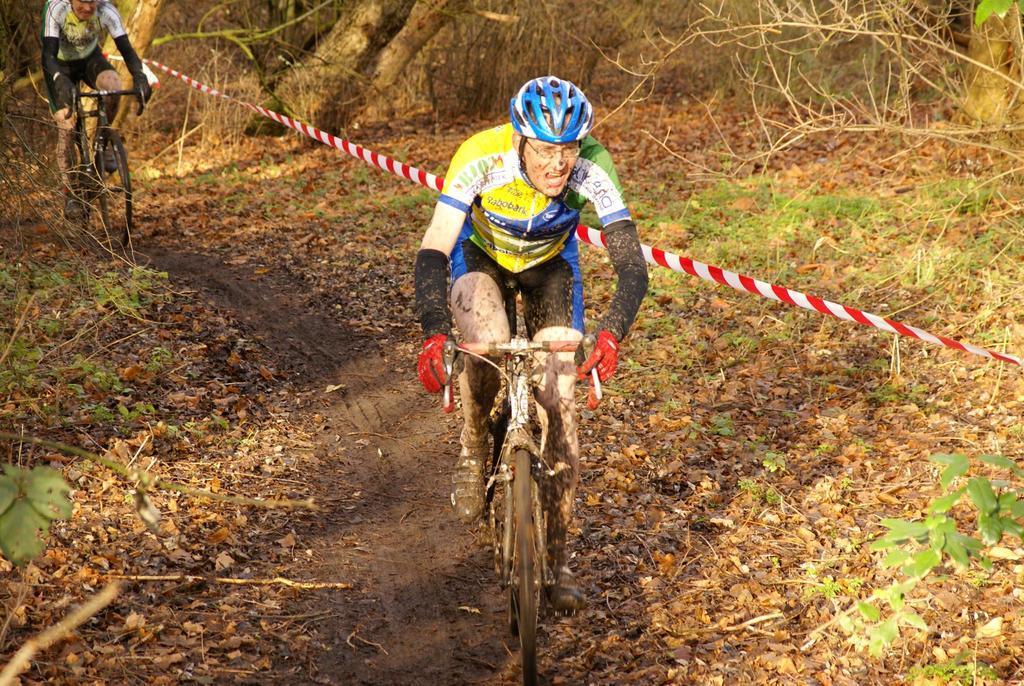How many people are in the image? There are two people in the image. What are the people wearing on their heads? The people are wearing helmets. What activity are the people engaged in? The people are riding bicycles. What type of vegetation can be seen in the image? There are plants in the image. What additional objects can be seen on the ground? Dry leaves are present in the image. What is the rope used for in the image? The purpose of the rope is not clear from the image. How many babies are being carried by the ducks in the image? There are no ducks or babies present in the image. What type of sand can be seen on the ground in the image? There is no sand visible in the image; it features plants and dry leaves. 